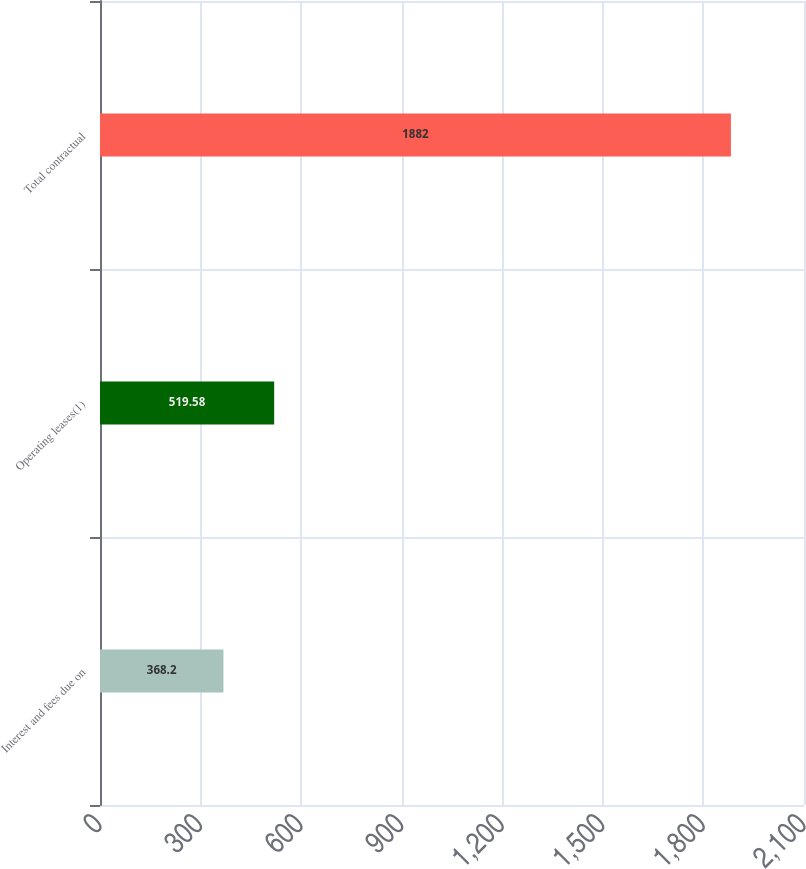Convert chart. <chart><loc_0><loc_0><loc_500><loc_500><bar_chart><fcel>Interest and fees due on<fcel>Operating leases(1)<fcel>Total contractual<nl><fcel>368.2<fcel>519.58<fcel>1882<nl></chart> 